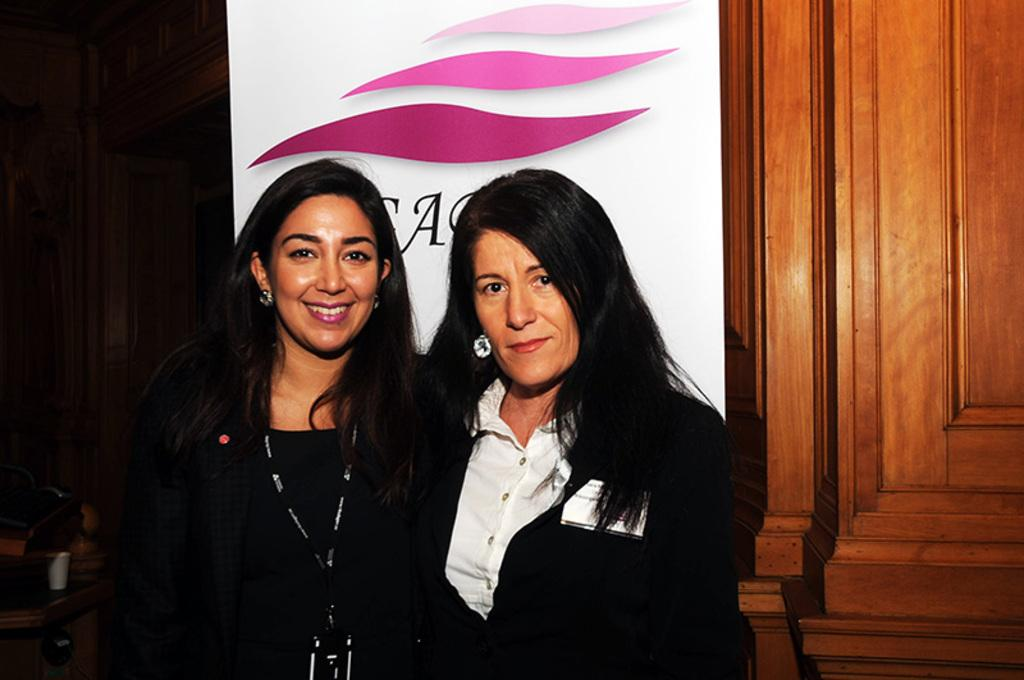How many women are in the image? There are two women in the image. What expression do the women have? The women are smiling. What can be seen in the background of the image? There is a banner with text and a wooden door visible in the background. Where is the cup located in the image? The cup is on a table on the left side of the image. Can you tell me how many flies are on the cup in the image? There are no flies present on the cup or in the image. Is there a camp visible in the background of the image? There is no camp visible in the image; it features two women, a banner, a wooden door, and a cup on a table. 